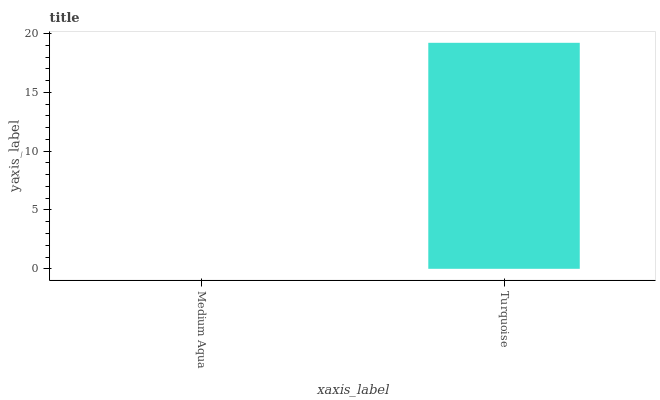Is Turquoise the minimum?
Answer yes or no. No. Is Turquoise greater than Medium Aqua?
Answer yes or no. Yes. Is Medium Aqua less than Turquoise?
Answer yes or no. Yes. Is Medium Aqua greater than Turquoise?
Answer yes or no. No. Is Turquoise less than Medium Aqua?
Answer yes or no. No. Is Turquoise the high median?
Answer yes or no. Yes. Is Medium Aqua the low median?
Answer yes or no. Yes. Is Medium Aqua the high median?
Answer yes or no. No. Is Turquoise the low median?
Answer yes or no. No. 